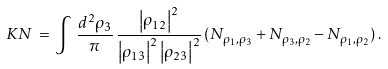Convert formula to latex. <formula><loc_0><loc_0><loc_500><loc_500>\, K N \, = \, \int \, \frac { d ^ { 2 } \rho _ { 3 } } { \pi } \, \frac { \left | \rho _ { 1 2 } \right | ^ { 2 } } { \left | \rho _ { 1 3 } \right | ^ { 2 } \left | \rho _ { 2 3 } \right | ^ { 2 } } \, ( N _ { \rho _ { 1 } , \rho _ { 3 } } + N _ { \rho _ { 3 } , \rho _ { 2 } } - N _ { \rho _ { 1 } , \rho _ { 2 } } ) \, .</formula> 